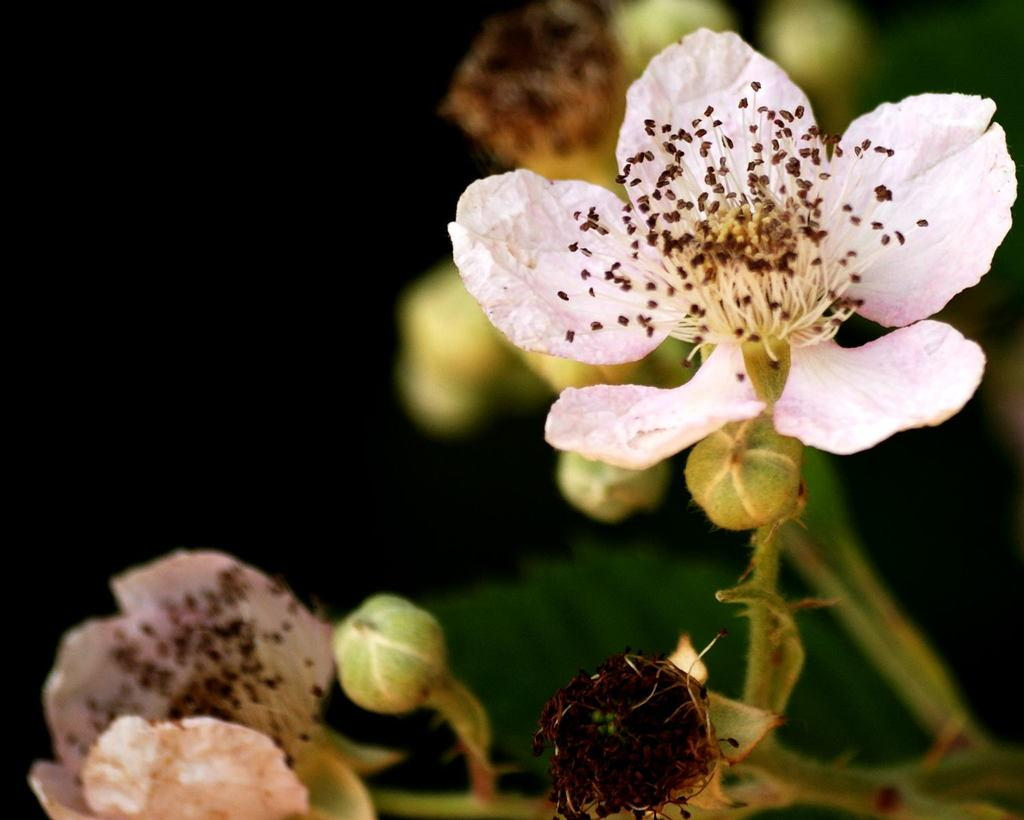What is the main subject of the image? There is a flower in the image. Are there any other parts of the flower visible in the image? Yes, there are buds in the image. Can you describe the background of the image? The background of the image is blurry. What type of border can be seen around the flower in the image? There is no border visible around the flower in the image. Can you tell me how many bats are flying around the flower in the image? There are no bats present in the image; it features a flower and buds. 